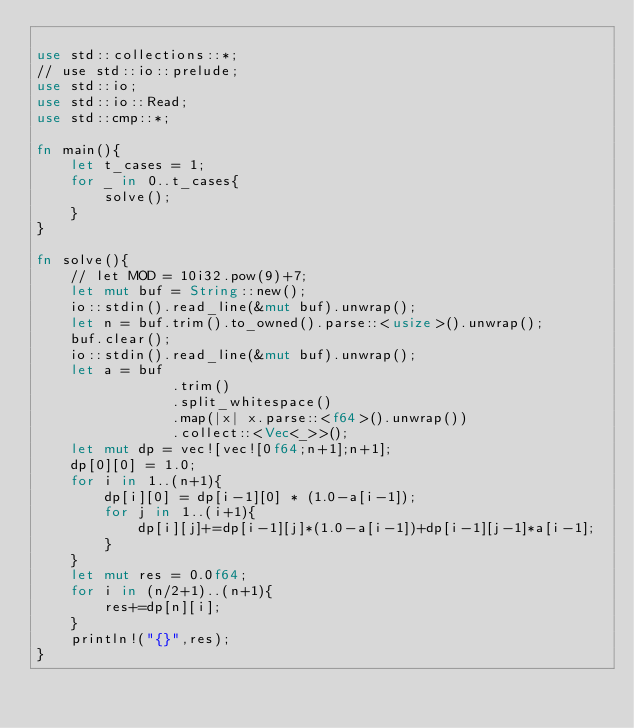<code> <loc_0><loc_0><loc_500><loc_500><_Rust_>
use std::collections::*;
// use std::io::prelude;
use std::io;
use std::io::Read;
use std::cmp::*;

fn main(){
    let t_cases = 1;
    for _ in 0..t_cases{
        solve();
    }
}

fn solve(){
    // let MOD = 10i32.pow(9)+7;
    let mut buf = String::new();
    io::stdin().read_line(&mut buf).unwrap();
    let n = buf.trim().to_owned().parse::<usize>().unwrap();
    buf.clear();
    io::stdin().read_line(&mut buf).unwrap();
    let a = buf
                .trim()
                .split_whitespace()
                .map(|x| x.parse::<f64>().unwrap())
                .collect::<Vec<_>>();
    let mut dp = vec![vec![0f64;n+1];n+1];
    dp[0][0] = 1.0;
    for i in 1..(n+1){
        dp[i][0] = dp[i-1][0] * (1.0-a[i-1]);
        for j in 1..(i+1){
            dp[i][j]+=dp[i-1][j]*(1.0-a[i-1])+dp[i-1][j-1]*a[i-1];
        }
    }
    let mut res = 0.0f64;
    for i in (n/2+1)..(n+1){
        res+=dp[n][i];
    }
    println!("{}",res);
}</code> 